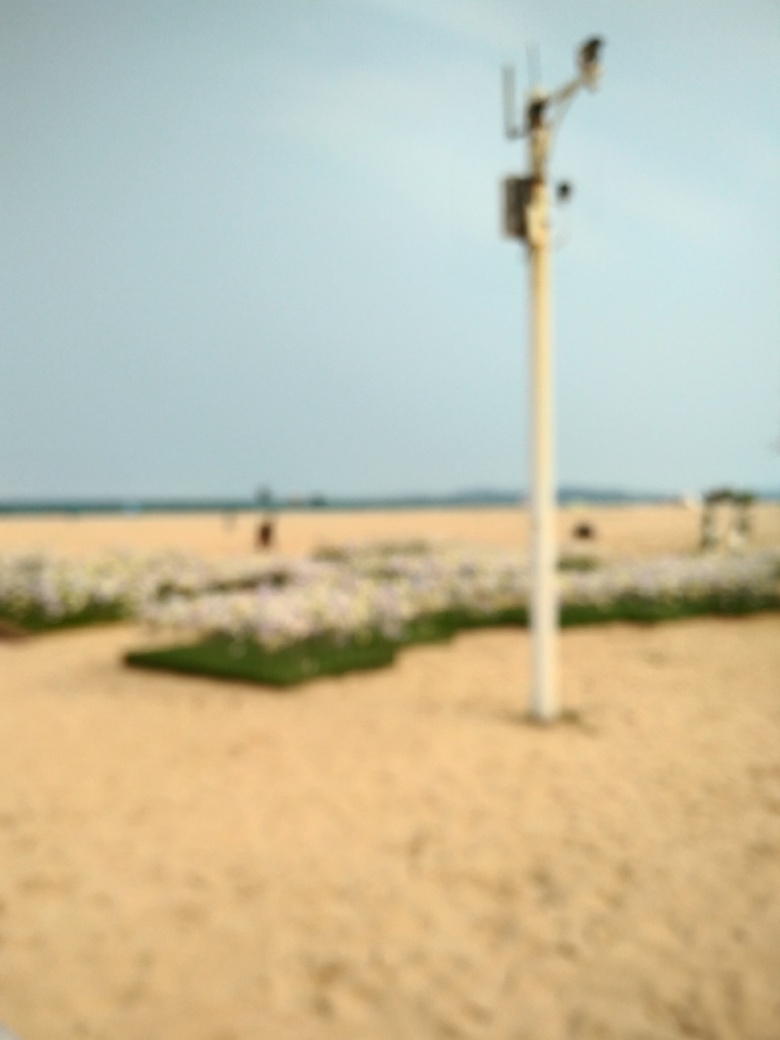Is there any indication of human activity or presence in this image? The image is too blurred to determine specifics; however, what appears to be a small, indistinct figure in the distance could suggest human presence. The setting, which implies a public space, also supports the likelihood of human activity even though it's not clearly visible. 